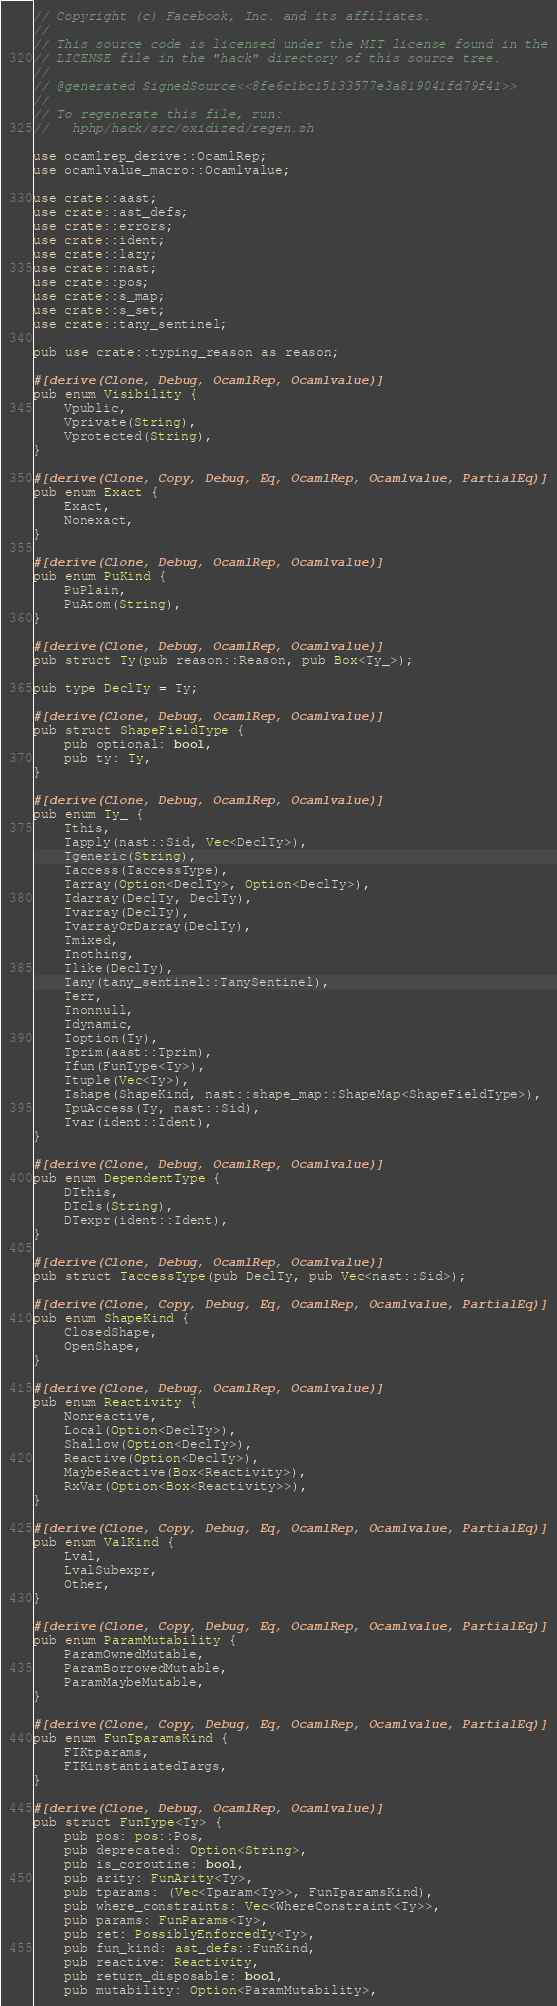<code> <loc_0><loc_0><loc_500><loc_500><_Rust_>// Copyright (c) Facebook, Inc. and its affiliates.
//
// This source code is licensed under the MIT license found in the
// LICENSE file in the "hack" directory of this source tree.
//
// @generated SignedSource<<8fe6c1bc15133577e3a819041fd79f41>>
//
// To regenerate this file, run:
//   hphp/hack/src/oxidized/regen.sh

use ocamlrep_derive::OcamlRep;
use ocamlvalue_macro::Ocamlvalue;

use crate::aast;
use crate::ast_defs;
use crate::errors;
use crate::ident;
use crate::lazy;
use crate::nast;
use crate::pos;
use crate::s_map;
use crate::s_set;
use crate::tany_sentinel;

pub use crate::typing_reason as reason;

#[derive(Clone, Debug, OcamlRep, Ocamlvalue)]
pub enum Visibility {
    Vpublic,
    Vprivate(String),
    Vprotected(String),
}

#[derive(Clone, Copy, Debug, Eq, OcamlRep, Ocamlvalue, PartialEq)]
pub enum Exact {
    Exact,
    Nonexact,
}

#[derive(Clone, Debug, OcamlRep, Ocamlvalue)]
pub enum PuKind {
    PuPlain,
    PuAtom(String),
}

#[derive(Clone, Debug, OcamlRep, Ocamlvalue)]
pub struct Ty(pub reason::Reason, pub Box<Ty_>);

pub type DeclTy = Ty;

#[derive(Clone, Debug, OcamlRep, Ocamlvalue)]
pub struct ShapeFieldType {
    pub optional: bool,
    pub ty: Ty,
}

#[derive(Clone, Debug, OcamlRep, Ocamlvalue)]
pub enum Ty_ {
    Tthis,
    Tapply(nast::Sid, Vec<DeclTy>),
    Tgeneric(String),
    Taccess(TaccessType),
    Tarray(Option<DeclTy>, Option<DeclTy>),
    Tdarray(DeclTy, DeclTy),
    Tvarray(DeclTy),
    TvarrayOrDarray(DeclTy),
    Tmixed,
    Tnothing,
    Tlike(DeclTy),
    Tany(tany_sentinel::TanySentinel),
    Terr,
    Tnonnull,
    Tdynamic,
    Toption(Ty),
    Tprim(aast::Tprim),
    Tfun(FunType<Ty>),
    Ttuple(Vec<Ty>),
    Tshape(ShapeKind, nast::shape_map::ShapeMap<ShapeFieldType>),
    TpuAccess(Ty, nast::Sid),
    Tvar(ident::Ident),
}

#[derive(Clone, Debug, OcamlRep, Ocamlvalue)]
pub enum DependentType {
    DTthis,
    DTcls(String),
    DTexpr(ident::Ident),
}

#[derive(Clone, Debug, OcamlRep, Ocamlvalue)]
pub struct TaccessType(pub DeclTy, pub Vec<nast::Sid>);

#[derive(Clone, Copy, Debug, Eq, OcamlRep, Ocamlvalue, PartialEq)]
pub enum ShapeKind {
    ClosedShape,
    OpenShape,
}

#[derive(Clone, Debug, OcamlRep, Ocamlvalue)]
pub enum Reactivity {
    Nonreactive,
    Local(Option<DeclTy>),
    Shallow(Option<DeclTy>),
    Reactive(Option<DeclTy>),
    MaybeReactive(Box<Reactivity>),
    RxVar(Option<Box<Reactivity>>),
}

#[derive(Clone, Copy, Debug, Eq, OcamlRep, Ocamlvalue, PartialEq)]
pub enum ValKind {
    Lval,
    LvalSubexpr,
    Other,
}

#[derive(Clone, Copy, Debug, Eq, OcamlRep, Ocamlvalue, PartialEq)]
pub enum ParamMutability {
    ParamOwnedMutable,
    ParamBorrowedMutable,
    ParamMaybeMutable,
}

#[derive(Clone, Copy, Debug, Eq, OcamlRep, Ocamlvalue, PartialEq)]
pub enum FunTparamsKind {
    FTKtparams,
    FTKinstantiatedTargs,
}

#[derive(Clone, Debug, OcamlRep, Ocamlvalue)]
pub struct FunType<Ty> {
    pub pos: pos::Pos,
    pub deprecated: Option<String>,
    pub is_coroutine: bool,
    pub arity: FunArity<Ty>,
    pub tparams: (Vec<Tparam<Ty>>, FunTparamsKind),
    pub where_constraints: Vec<WhereConstraint<Ty>>,
    pub params: FunParams<Ty>,
    pub ret: PossiblyEnforcedTy<Ty>,
    pub fun_kind: ast_defs::FunKind,
    pub reactive: Reactivity,
    pub return_disposable: bool,
    pub mutability: Option<ParamMutability>,</code> 